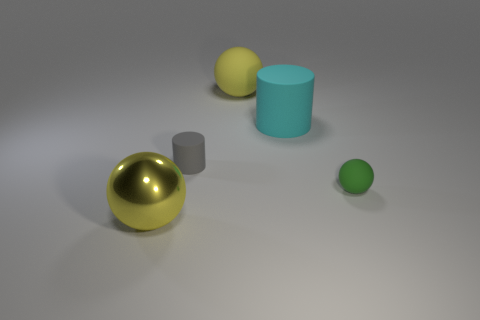What can you tell me about the lighting in this image? The lighting in the image appears soft and diffused, creating gentle shadows and a calm atmosphere. It seems to be coming primarily from above, suggesting an indoor setting with ambient light, perhaps from a ceiling fixture. 